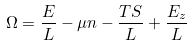Convert formula to latex. <formula><loc_0><loc_0><loc_500><loc_500>\Omega = \frac { E } { L } - \mu n - \frac { T S } { L } + \frac { E _ { z } } { L }</formula> 